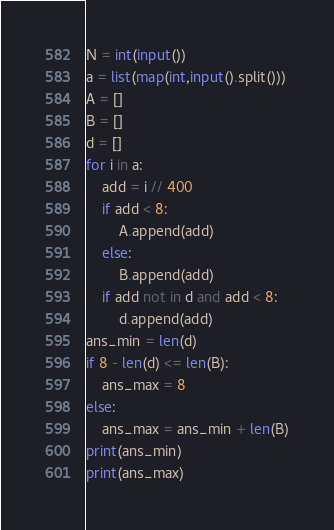<code> <loc_0><loc_0><loc_500><loc_500><_Python_>N = int(input())
a = list(map(int,input().split()))
A = []
B = []
d = []
for i in a:
    add = i // 400
    if add < 8:
        A.append(add)
    else:
        B.append(add)
    if add not in d and add < 8:
        d.append(add)
ans_min = len(d)
if 8 - len(d) <= len(B):
    ans_max = 8
else:
    ans_max = ans_min + len(B)
print(ans_min)
print(ans_max)</code> 